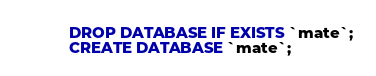<code> <loc_0><loc_0><loc_500><loc_500><_SQL_>DROP DATABASE IF EXISTS `mate`;
CREATE DATABASE `mate`;
</code> 